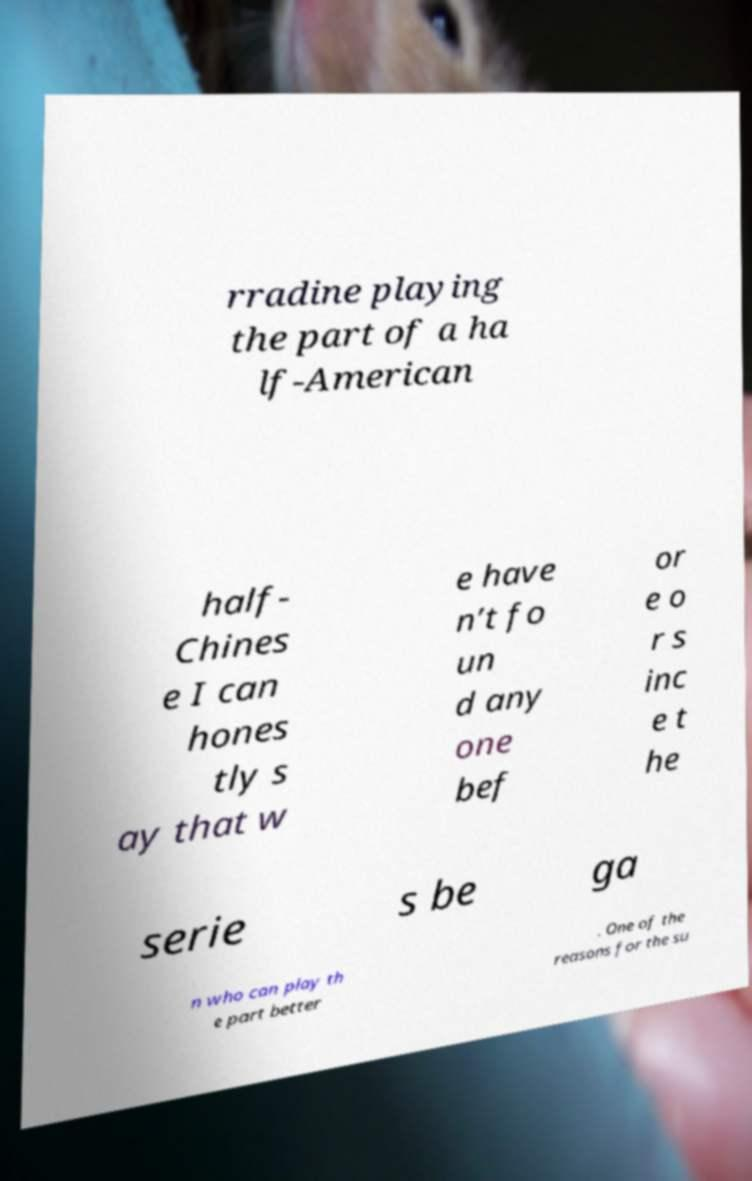Please read and relay the text visible in this image. What does it say? rradine playing the part of a ha lf-American half- Chines e I can hones tly s ay that w e have n’t fo un d any one bef or e o r s inc e t he serie s be ga n who can play th e part better . One of the reasons for the su 